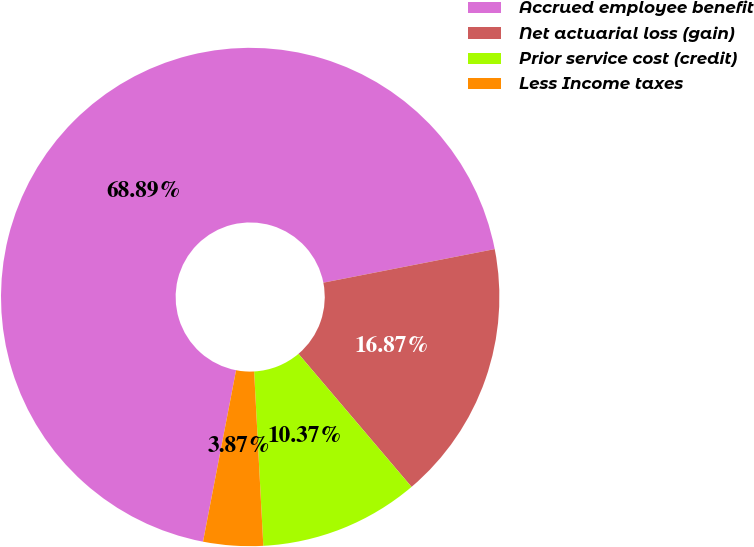<chart> <loc_0><loc_0><loc_500><loc_500><pie_chart><fcel>Accrued employee benefit<fcel>Net actuarial loss (gain)<fcel>Prior service cost (credit)<fcel>Less Income taxes<nl><fcel>68.89%<fcel>16.87%<fcel>10.37%<fcel>3.87%<nl></chart> 